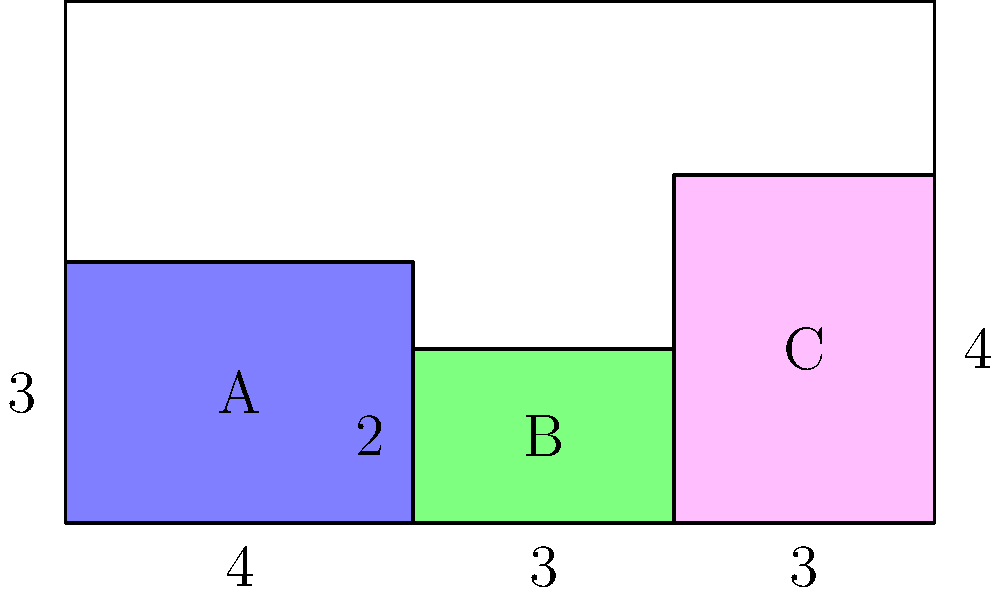As a bakery owner, you're organizing your display case to maximize visibility and sales. The case is 10 units wide and 6 units tall. You've placed three cakes (A, B, and C) as shown in the diagram. What is the total area of unused space in the display case? Let's approach this step-by-step:

1) First, let's calculate the total area of the display case:
   Total area = $10 \times 6 = 60$ square units

2) Now, let's calculate the area of each cake:
   Cake A: $4 \times 3 = 12$ square units
   Cake B: $3 \times 2 = 6$ square units
   Cake C: $3 \times 4 = 12$ square units

3) Sum up the areas of all cakes:
   Total cake area = $12 + 6 + 12 = 30$ square units

4) To find the unused space, we subtract the total cake area from the total display case area:
   Unused space = Total area - Total cake area
                = $60 - 30 = 30$ square units

Therefore, the total area of unused space in the display case is 30 square units.
Answer: 30 square units 